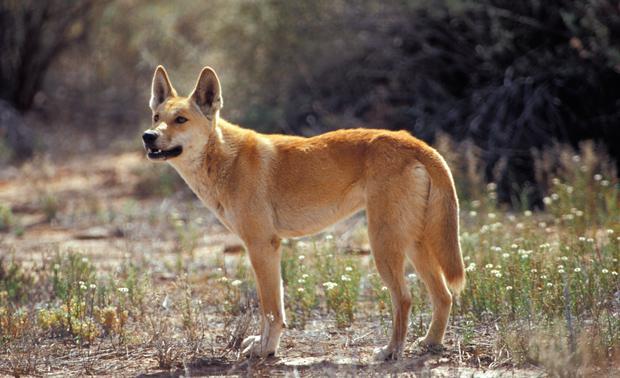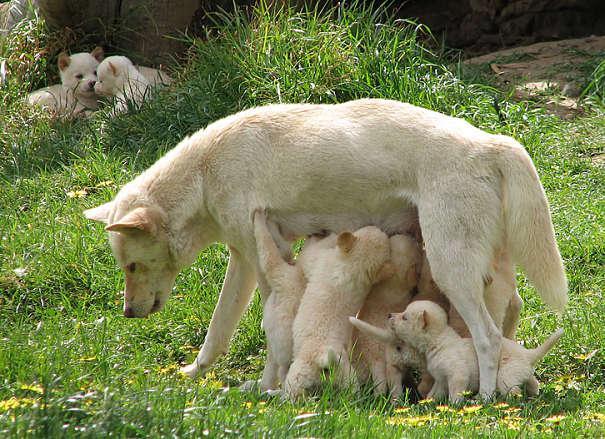The first image is the image on the left, the second image is the image on the right. Examine the images to the left and right. Is the description "An image shows an adult dog with at least one pup standing to reach it." accurate? Answer yes or no. Yes. The first image is the image on the left, the second image is the image on the right. Examine the images to the left and right. Is the description "There is only one animal in the picture on the left." accurate? Answer yes or no. Yes. 